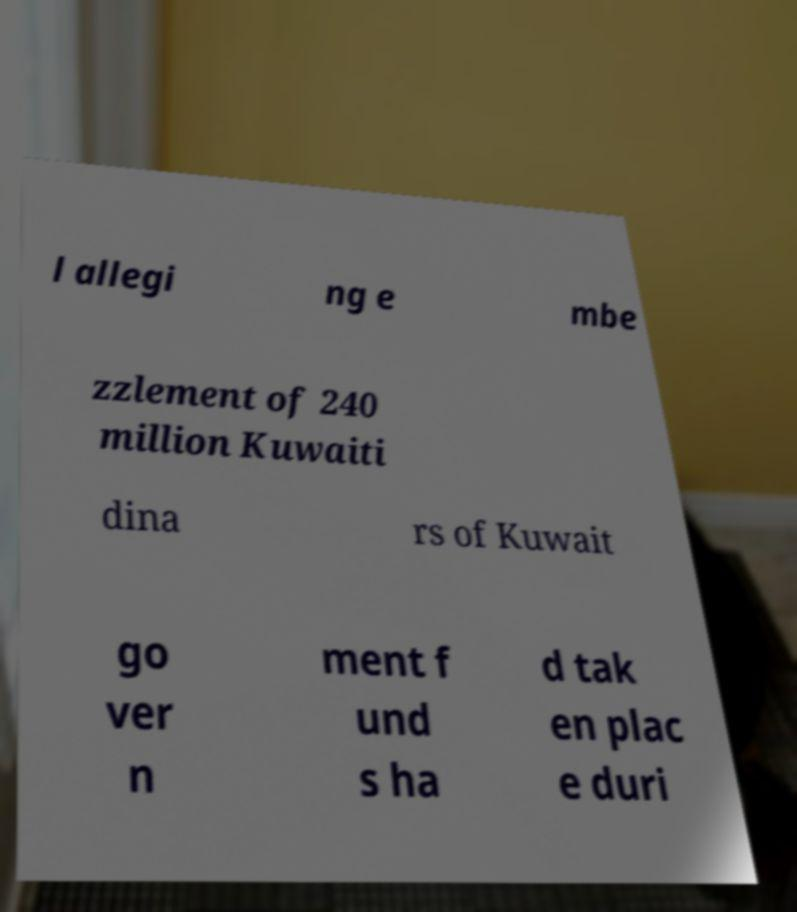There's text embedded in this image that I need extracted. Can you transcribe it verbatim? l allegi ng e mbe zzlement of 240 million Kuwaiti dina rs of Kuwait go ver n ment f und s ha d tak en plac e duri 